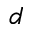<formula> <loc_0><loc_0><loc_500><loc_500>d</formula> 